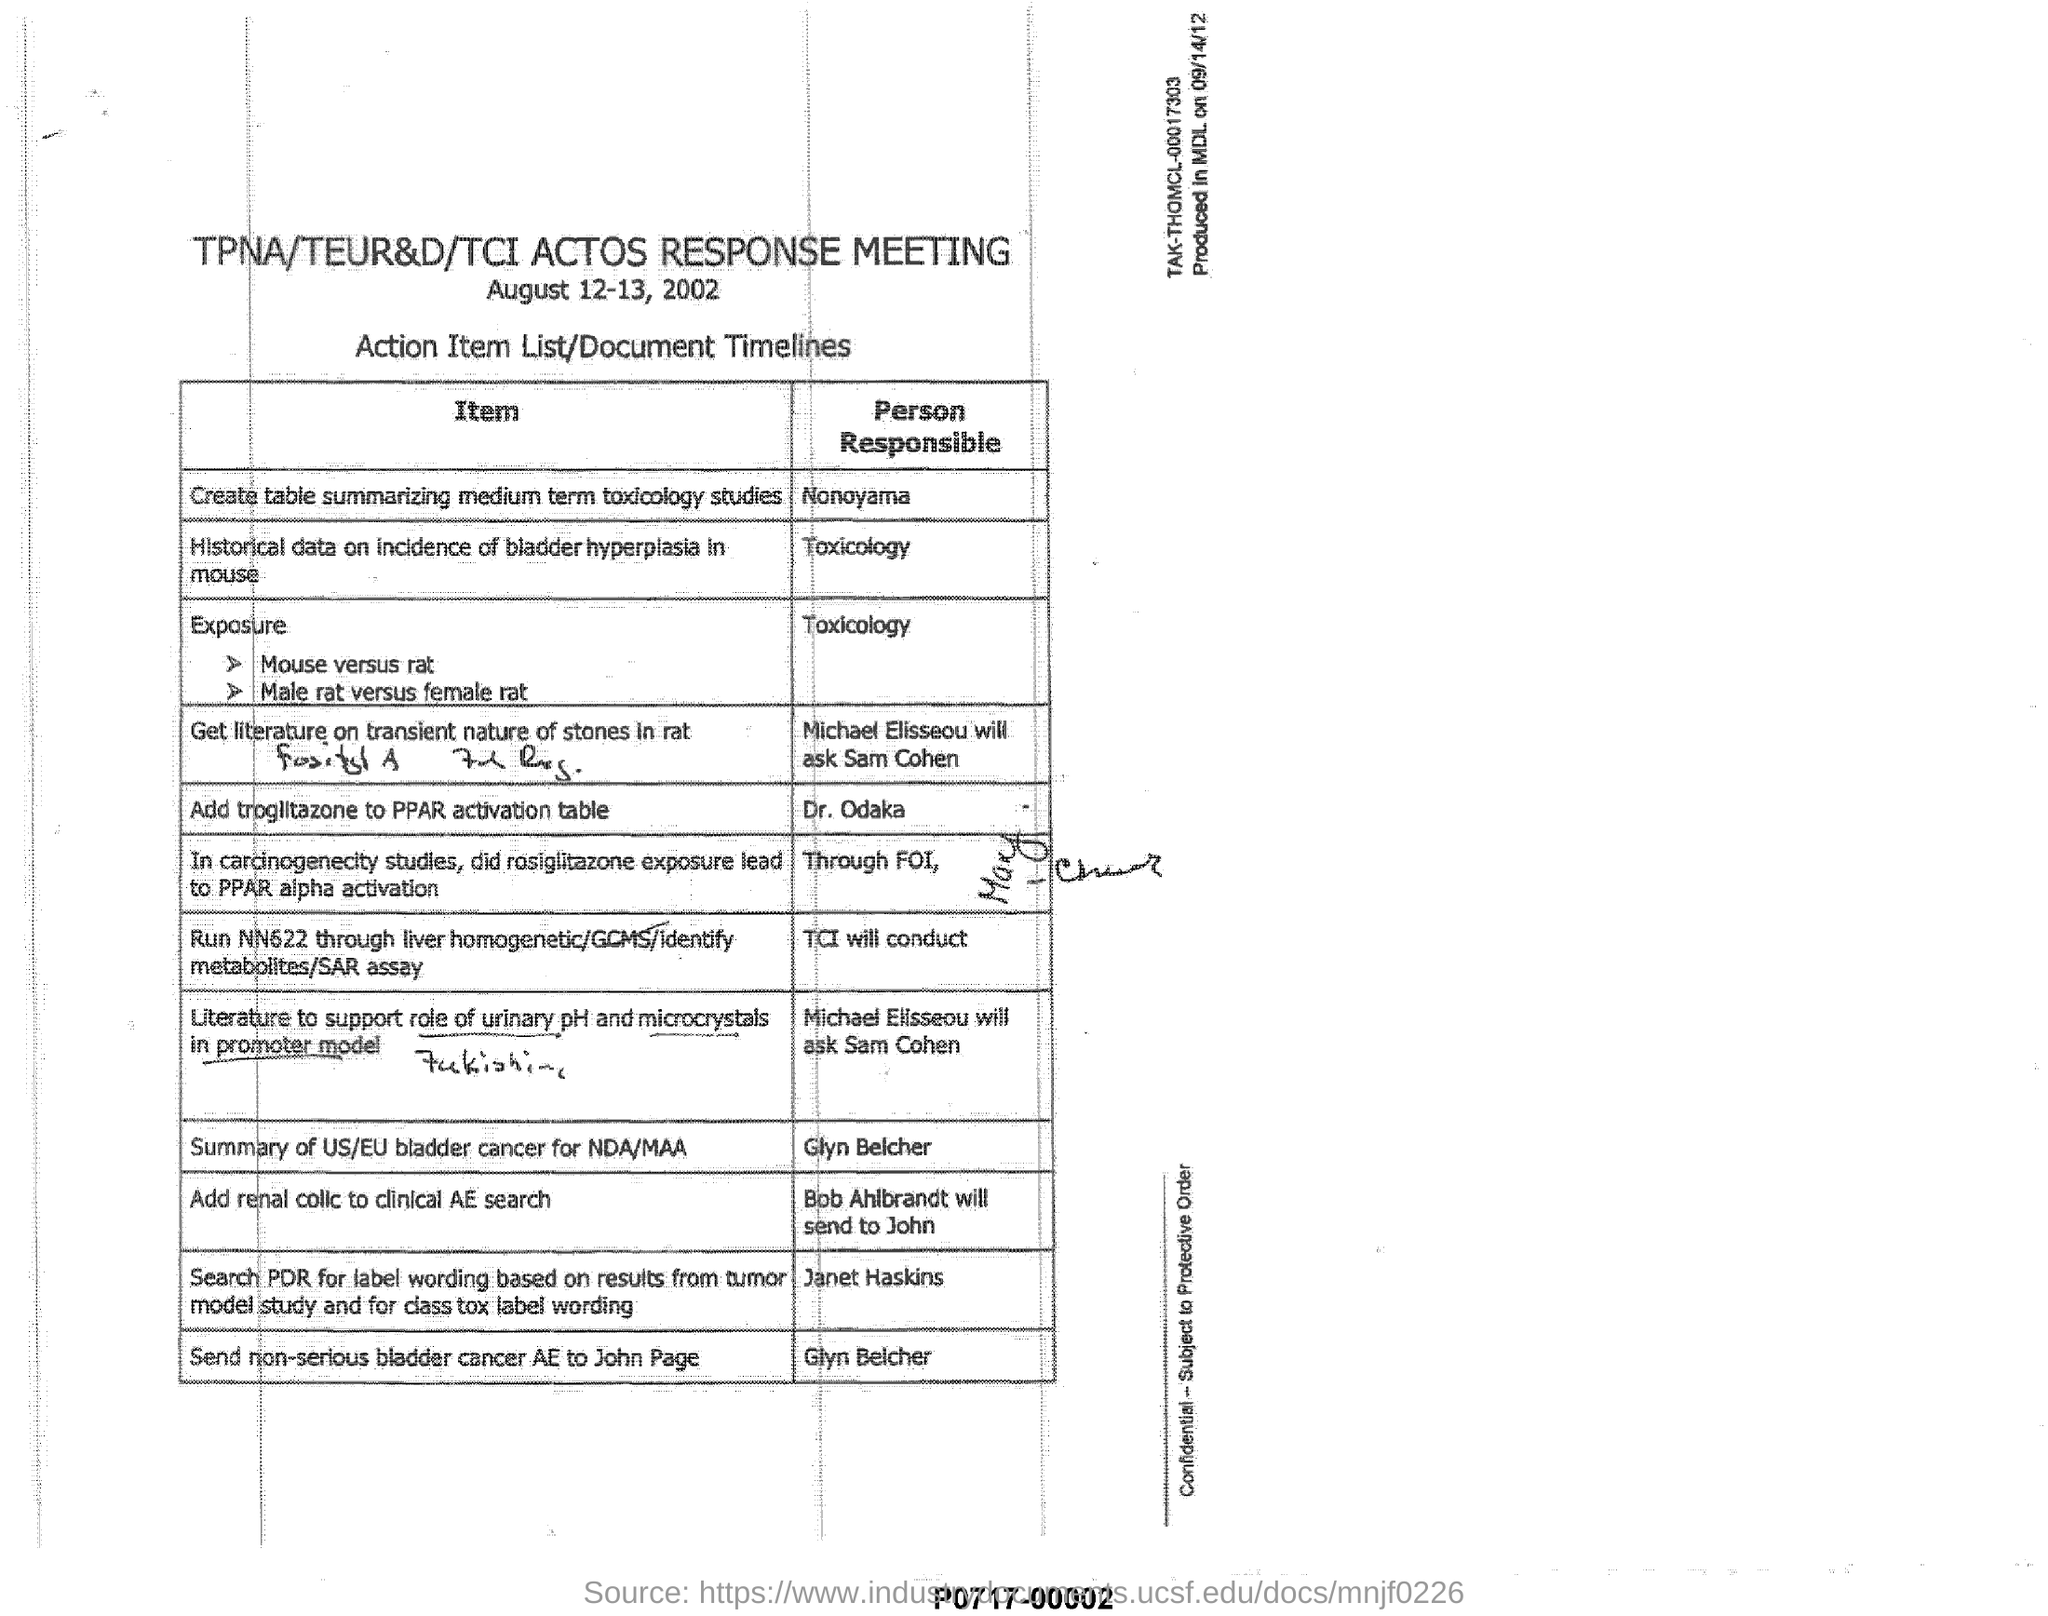What is the date mentioned?
Your answer should be compact. August 12-13, 2002. What is the Item that shows Person Responsible Bob Ahlbrandt will send to John?
Your answer should be very brief. Add renal colic to clinical AE search. What is the heading of the document?
Offer a very short reply. TPNA/TEUR&D/TCI ACTOS RESPONSE MEETING. What is written just below the date?
Provide a short and direct response. Action Item List/Document Timelines. 